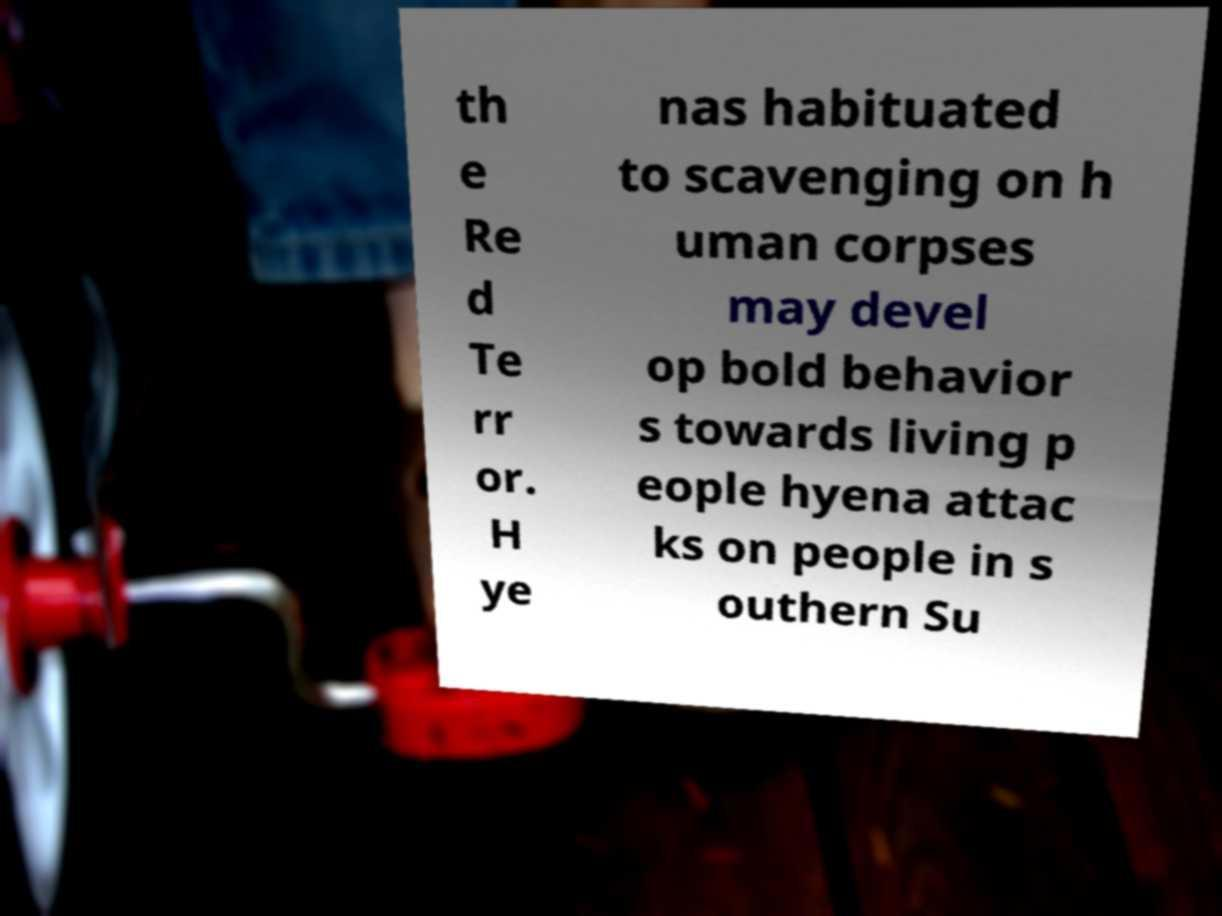Could you assist in decoding the text presented in this image and type it out clearly? th e Re d Te rr or. H ye nas habituated to scavenging on h uman corpses may devel op bold behavior s towards living p eople hyena attac ks on people in s outhern Su 